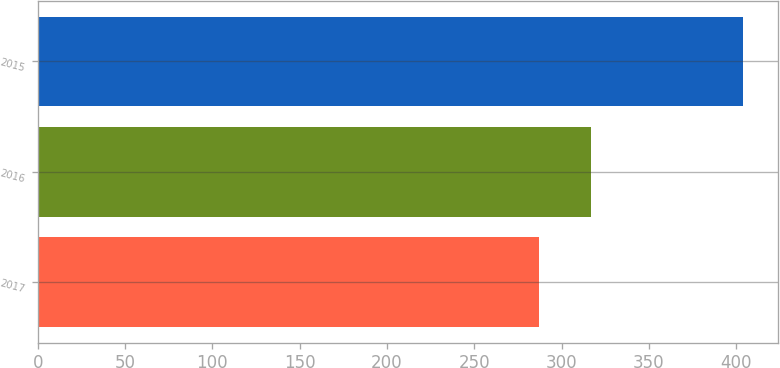<chart> <loc_0><loc_0><loc_500><loc_500><bar_chart><fcel>2017<fcel>2016<fcel>2015<nl><fcel>287<fcel>317<fcel>404<nl></chart> 